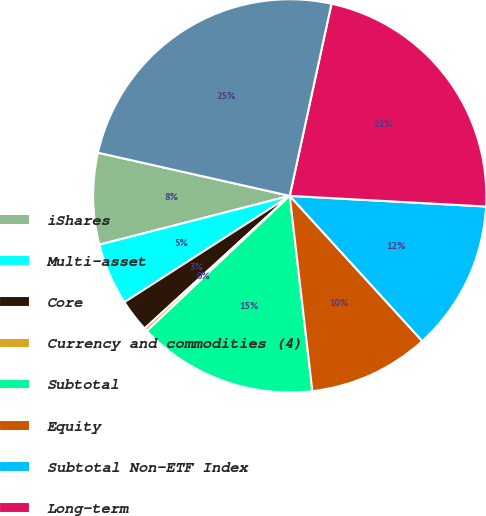Convert chart to OTSL. <chart><loc_0><loc_0><loc_500><loc_500><pie_chart><fcel>iShares<fcel>Multi-asset<fcel>Core<fcel>Currency and commodities (4)<fcel>Subtotal<fcel>Equity<fcel>Subtotal Non-ETF Index<fcel>Long-term<fcel>Total<nl><fcel>7.52%<fcel>5.1%<fcel>2.69%<fcel>0.27%<fcel>14.78%<fcel>9.94%<fcel>12.36%<fcel>22.46%<fcel>24.88%<nl></chart> 